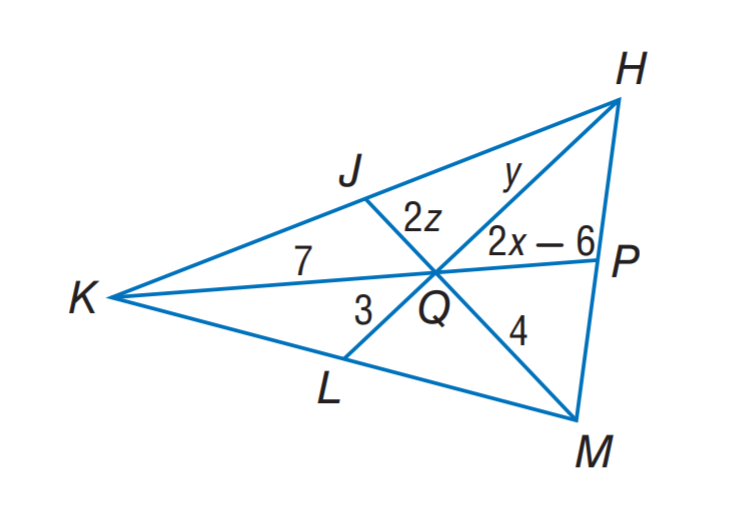Answer the mathemtical geometry problem and directly provide the correct option letter.
Question: If J, P, and L are the midpoints of K H, H M and M K, respectively. Find y.
Choices: A: 3 B: 4 C: 6 D: 7 C 